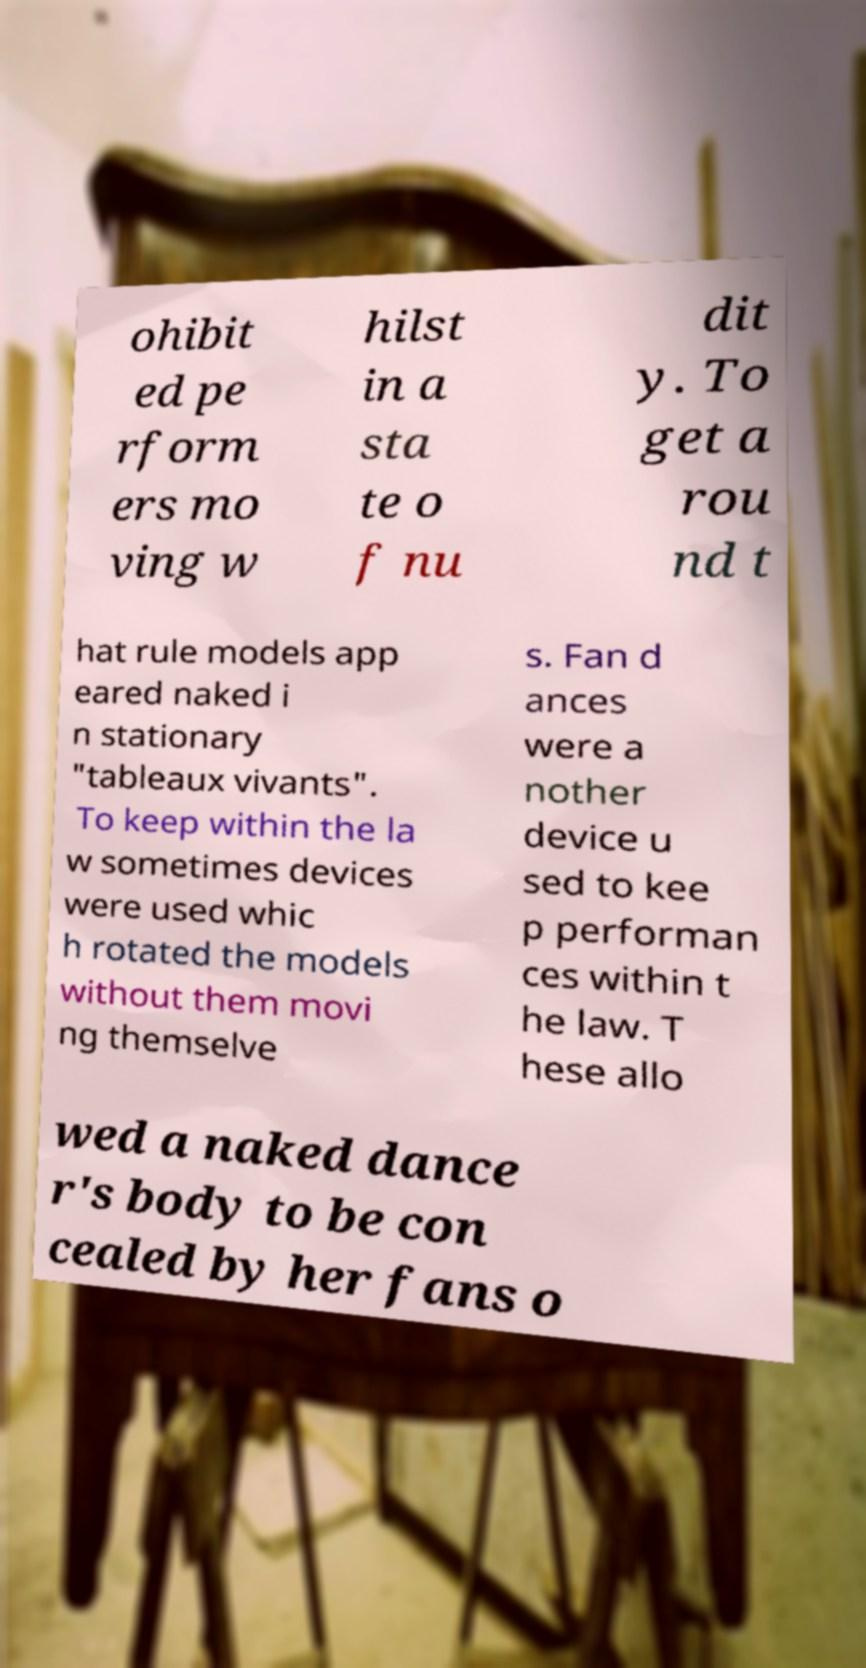What messages or text are displayed in this image? I need them in a readable, typed format. ohibit ed pe rform ers mo ving w hilst in a sta te o f nu dit y. To get a rou nd t hat rule models app eared naked i n stationary "tableaux vivants". To keep within the la w sometimes devices were used whic h rotated the models without them movi ng themselve s. Fan d ances were a nother device u sed to kee p performan ces within t he law. T hese allo wed a naked dance r's body to be con cealed by her fans o 